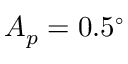<formula> <loc_0><loc_0><loc_500><loc_500>A _ { p } = 0 . 5 ^ { \circ }</formula> 